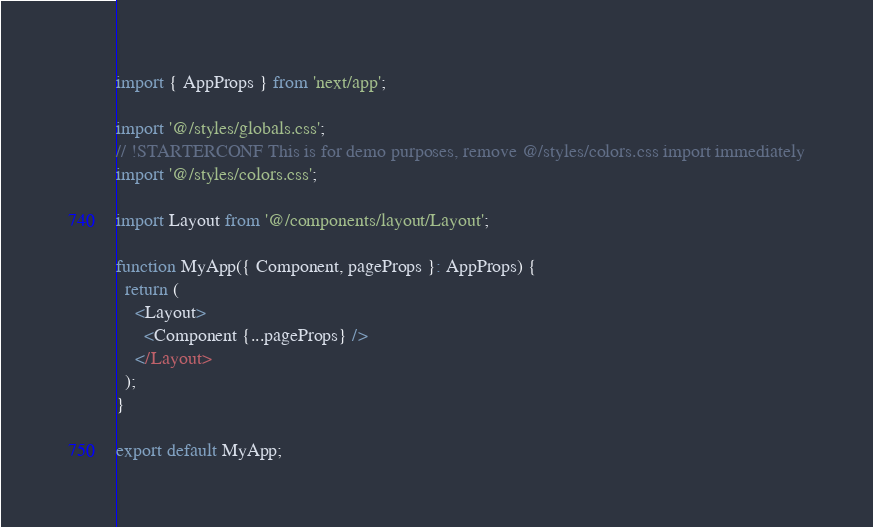Convert code to text. <code><loc_0><loc_0><loc_500><loc_500><_TypeScript_>import { AppProps } from 'next/app';

import '@/styles/globals.css';
// !STARTERCONF This is for demo purposes, remove @/styles/colors.css import immediately
import '@/styles/colors.css';

import Layout from '@/components/layout/Layout';

function MyApp({ Component, pageProps }: AppProps) {
  return (
    <Layout>
      <Component {...pageProps} />
    </Layout>
  );
}

export default MyApp;
</code> 